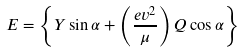<formula> <loc_0><loc_0><loc_500><loc_500>E = \left \{ Y \sin \alpha + \left ( \frac { e v ^ { 2 } } { \mu } \right ) Q \cos \alpha \right \}</formula> 